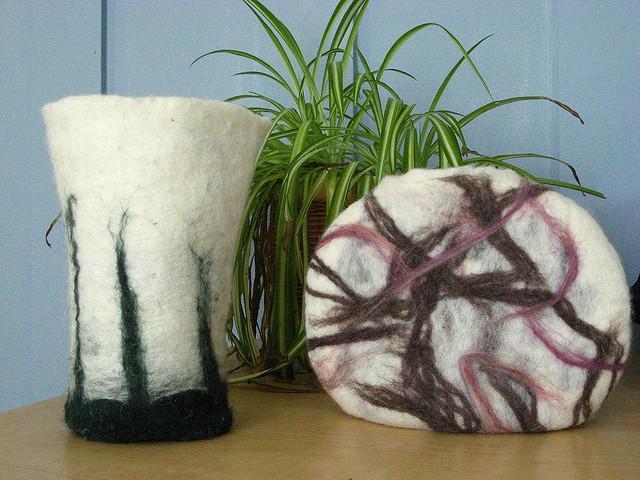How many vases can be seen?
Give a very brief answer. 2. 